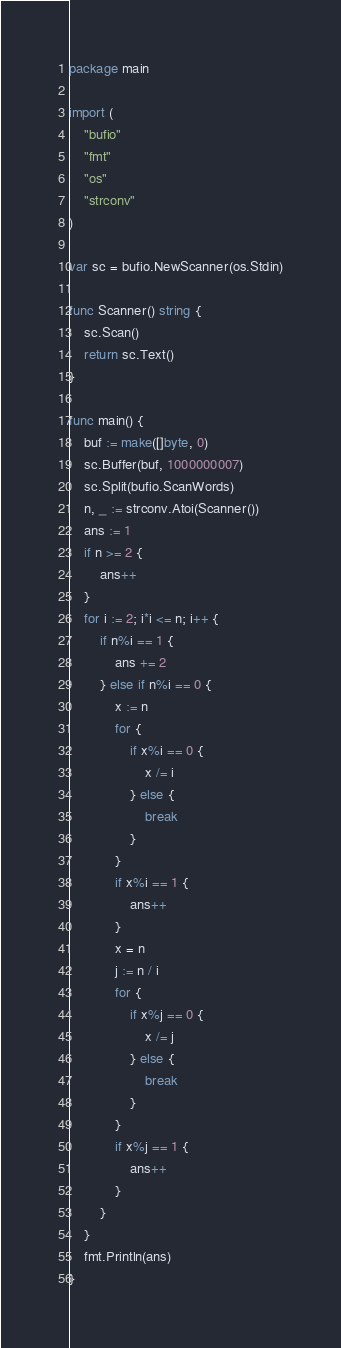<code> <loc_0><loc_0><loc_500><loc_500><_Go_>package main

import (
	"bufio"
	"fmt"
	"os"
	"strconv"
)

var sc = bufio.NewScanner(os.Stdin)

func Scanner() string {
	sc.Scan()
	return sc.Text()
}

func main() {
	buf := make([]byte, 0)
	sc.Buffer(buf, 1000000007)
	sc.Split(bufio.ScanWords)
	n, _ := strconv.Atoi(Scanner())
	ans := 1
	if n >= 2 {
		ans++
	}
	for i := 2; i*i <= n; i++ {
		if n%i == 1 {
			ans += 2
		} else if n%i == 0 {
			x := n
			for {
				if x%i == 0 {
					x /= i
				} else {
					break
				}
			}
			if x%i == 1 {
				ans++
			}
			x = n
			j := n / i
			for {
				if x%j == 0 {
					x /= j
				} else {
					break
				}
			}
			if x%j == 1 {
				ans++
			}
		}
	}
	fmt.Println(ans)
}
</code> 